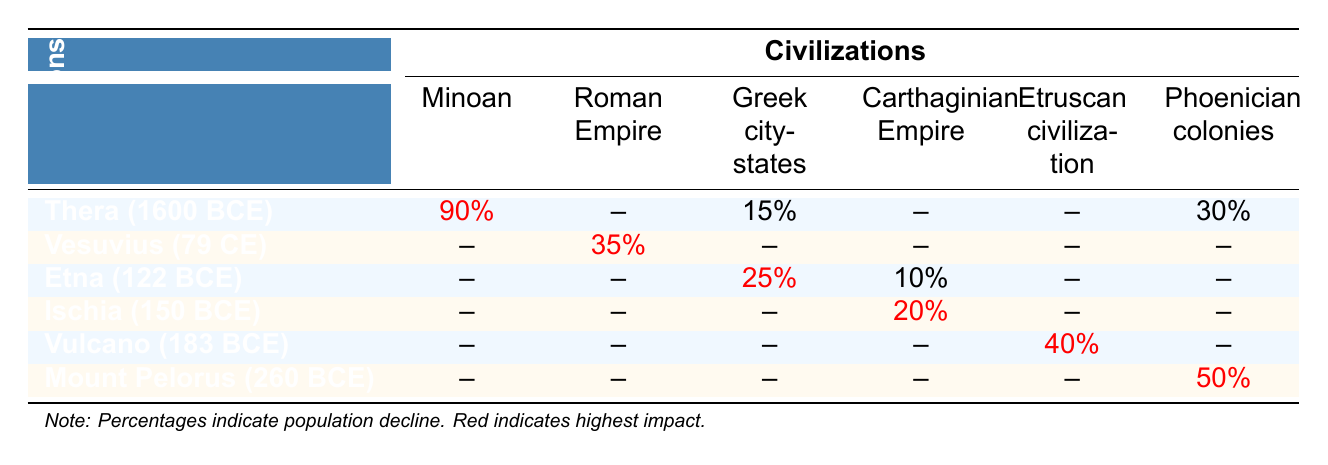What percentage of the population declined in the Minoan civilization due to the Thera eruption? The table indicates a population decline of 90% for the Minoan civilization due to the Thera eruption, as shown in the corresponding cell.
Answer: 90% Which civilization experienced a 35% population decline during the Vesuvius eruption? According to the table, the Roman Empire had a 35% decline in population due to the Vesuvius eruption, which is clearly indicated in the cell for that eruption and civilization.
Answer: Roman Empire How much greater was the population decline in the Etruscan civilization compared to the Greek city-states due to the Vulcano eruption? The Etruscan civilization had a 40% decline, while the Greek city-states had no recorded decline (0%). The difference is 40% - 0% = 40%.
Answer: 40% Did any civilization experience a population decline due to the Mount Pelorus eruption? The table shows that the Phoenician colonies experienced a population decline of 50% due to the Mount Pelorus eruption, confirming that there was indeed a decline.
Answer: Yes What is the total percentage of population decline across all civilizations due to the Thera eruption? For the Thera eruption, the declines are 90% (Minoan), 0% (Roman Empire), 15% (Greek city-states), 0% (Carthaginian Empire), 0% (Etruscan civilization), and 30% (Phoenician colonies). Summing these gives 90 + 0 + 15 + 0 + 0 + 30 = 135%.
Answer: 135% Which volcanic eruption had the highest recorded population impact on civilizations? The Thera eruption caused the highest population impact with a recorded 90% decline in the Minoan civilization, which stands out clearly in the table.
Answer: Thera eruption Identify the civilization with the least population decline indicated in the table for any eruption. The Carthaginian Empire shows no population decline for the Thera and Ischia eruptions (0% for both), which is the least indicated.
Answer: Carthaginian Empire What is the average population decline for the Greek city-states across all eruptions? The Greek city-states experienced declines of 15% (Thera), 0% (Vesuvius), 25% (Etna), 0% (Ischia), 0% (Vulcano), and 0% (Mount Pelorus). The average is (15 + 0 + 25 + 0 + 0 + 0) / 6 = 40 / 6 ≈ 6.67%.
Answer: 6.67% Which eruption resulted in a population decline for both the Greek city-states and the Etruscan civilization? The Etna eruption recorded a 25% decline for the Greek city-states and a 0% for the Etruscan civilization. Etruscan civilization had no population decline, so this question indicates only one civilization experienced a decline.
Answer: Greek city-states only Was there any population decline recorded for the Roman Empire due to the Ischia eruption? The table shows a 0% decline for the Roman Empire during the Ischia eruption, indicating that there was no recorded decline.
Answer: No 